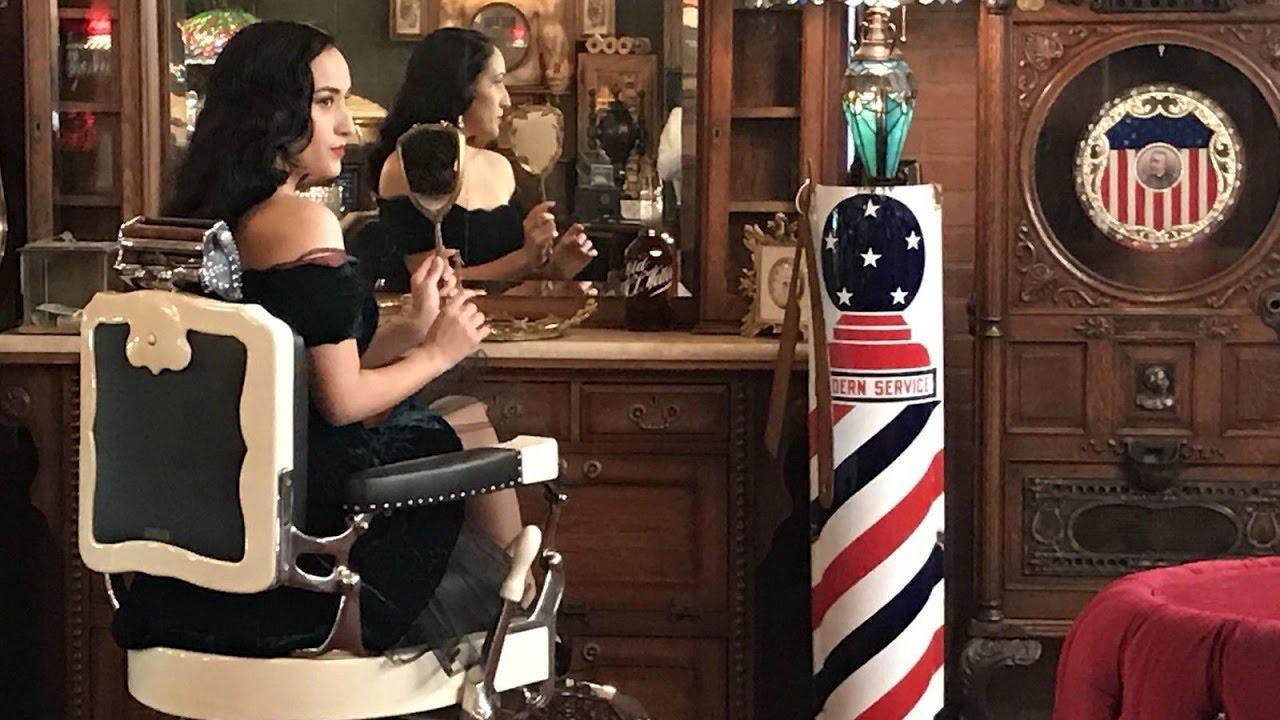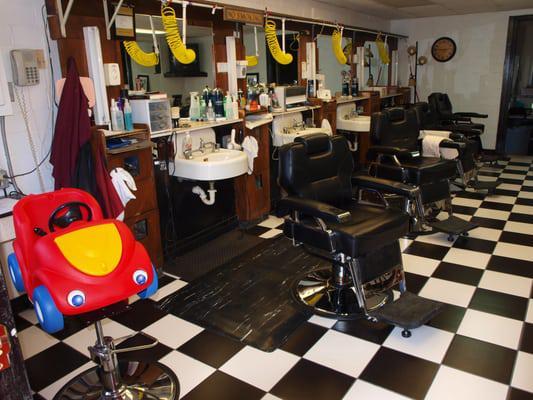The first image is the image on the left, the second image is the image on the right. Evaluate the accuracy of this statement regarding the images: "There are people in one image but not in the other image.". Is it true? Answer yes or no. Yes. The first image is the image on the left, the second image is the image on the right. Examine the images to the left and right. Is the description "There are no more than two people in total in the two shops." accurate? Answer yes or no. Yes. 